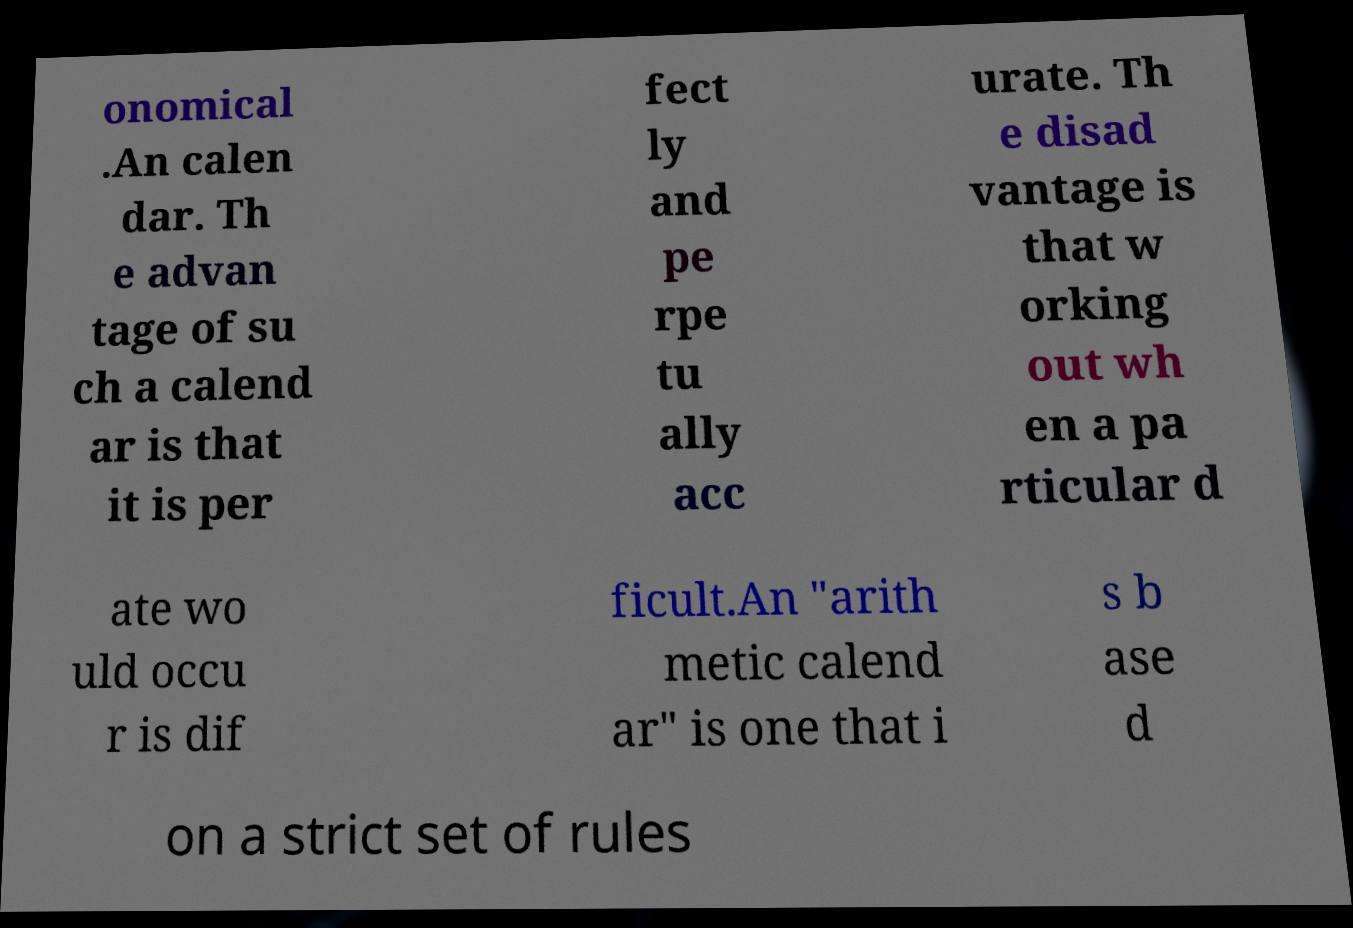For documentation purposes, I need the text within this image transcribed. Could you provide that? onomical .An calen dar. Th e advan tage of su ch a calend ar is that it is per fect ly and pe rpe tu ally acc urate. Th e disad vantage is that w orking out wh en a pa rticular d ate wo uld occu r is dif ficult.An "arith metic calend ar" is one that i s b ase d on a strict set of rules 